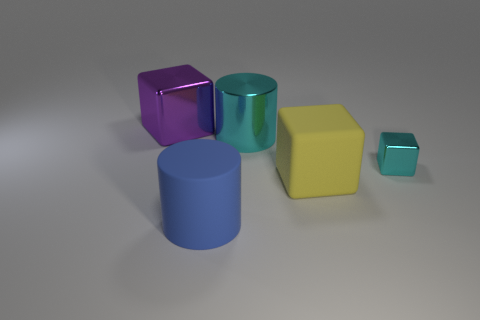Add 4 small cyan things. How many objects exist? 9 Subtract all blocks. How many objects are left? 2 Add 2 cyan cylinders. How many cyan cylinders exist? 3 Subtract 0 green cylinders. How many objects are left? 5 Subtract all large cyan things. Subtract all blue matte cylinders. How many objects are left? 3 Add 1 yellow things. How many yellow things are left? 2 